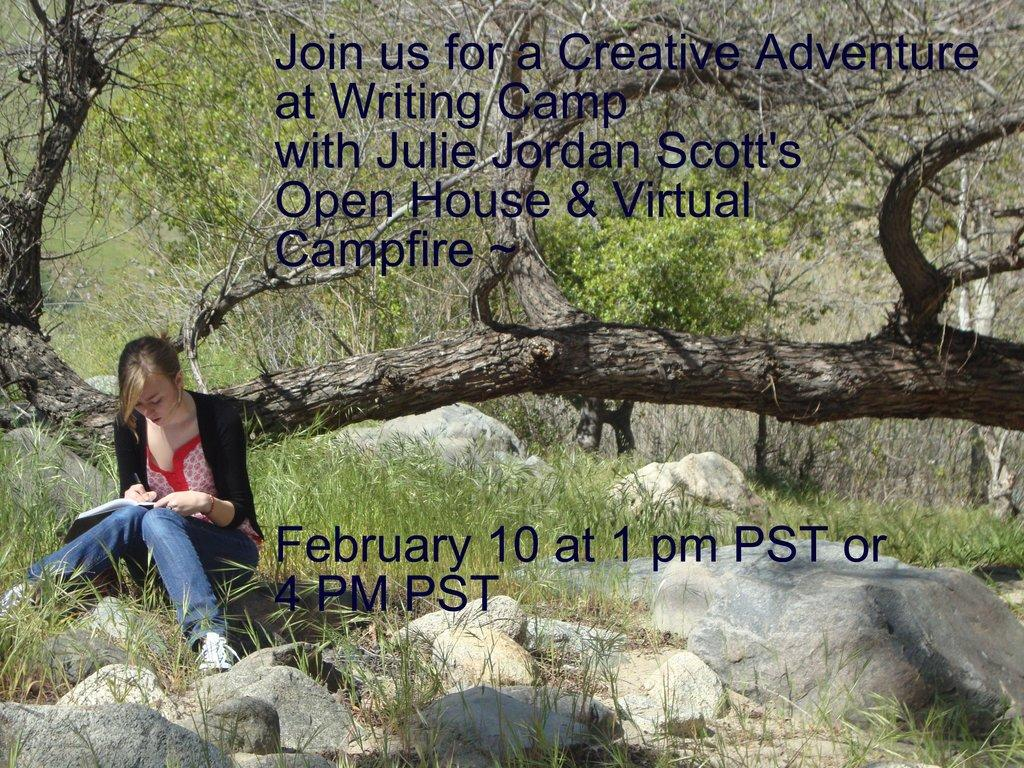What type of natural elements can be seen in the image? There are trees and rocks visible in the image. What can be read in the image? There is some text visible in the image. What is the lady in the image doing? The lady is sitting in the image and holding a book and a paper. What type of card is the lady holding in the image? There is no card visible in the image; the lady is holding a book and a paper. What condition does the lady request in the image? There is no indication of a request or condition in the image; the lady is simply sitting and holding a book and a paper. 